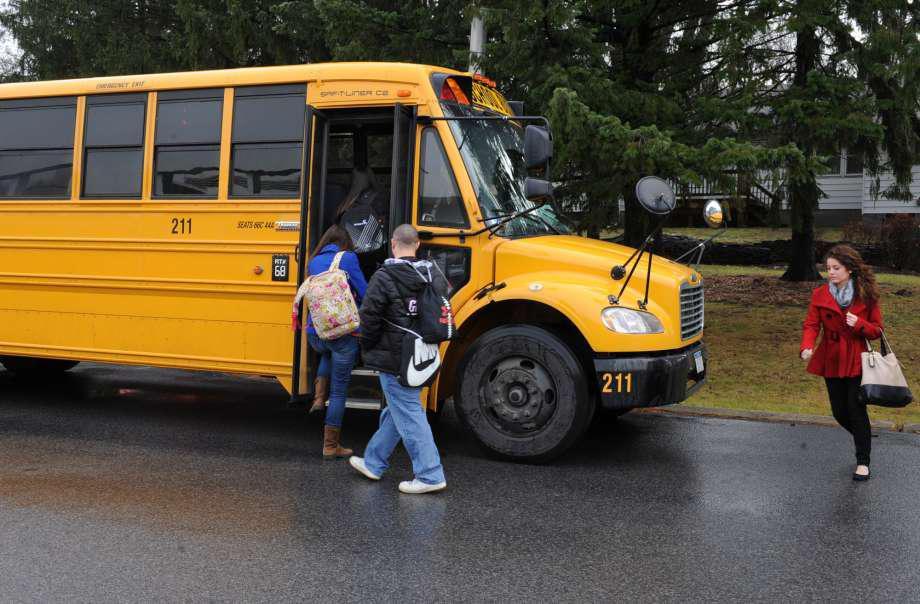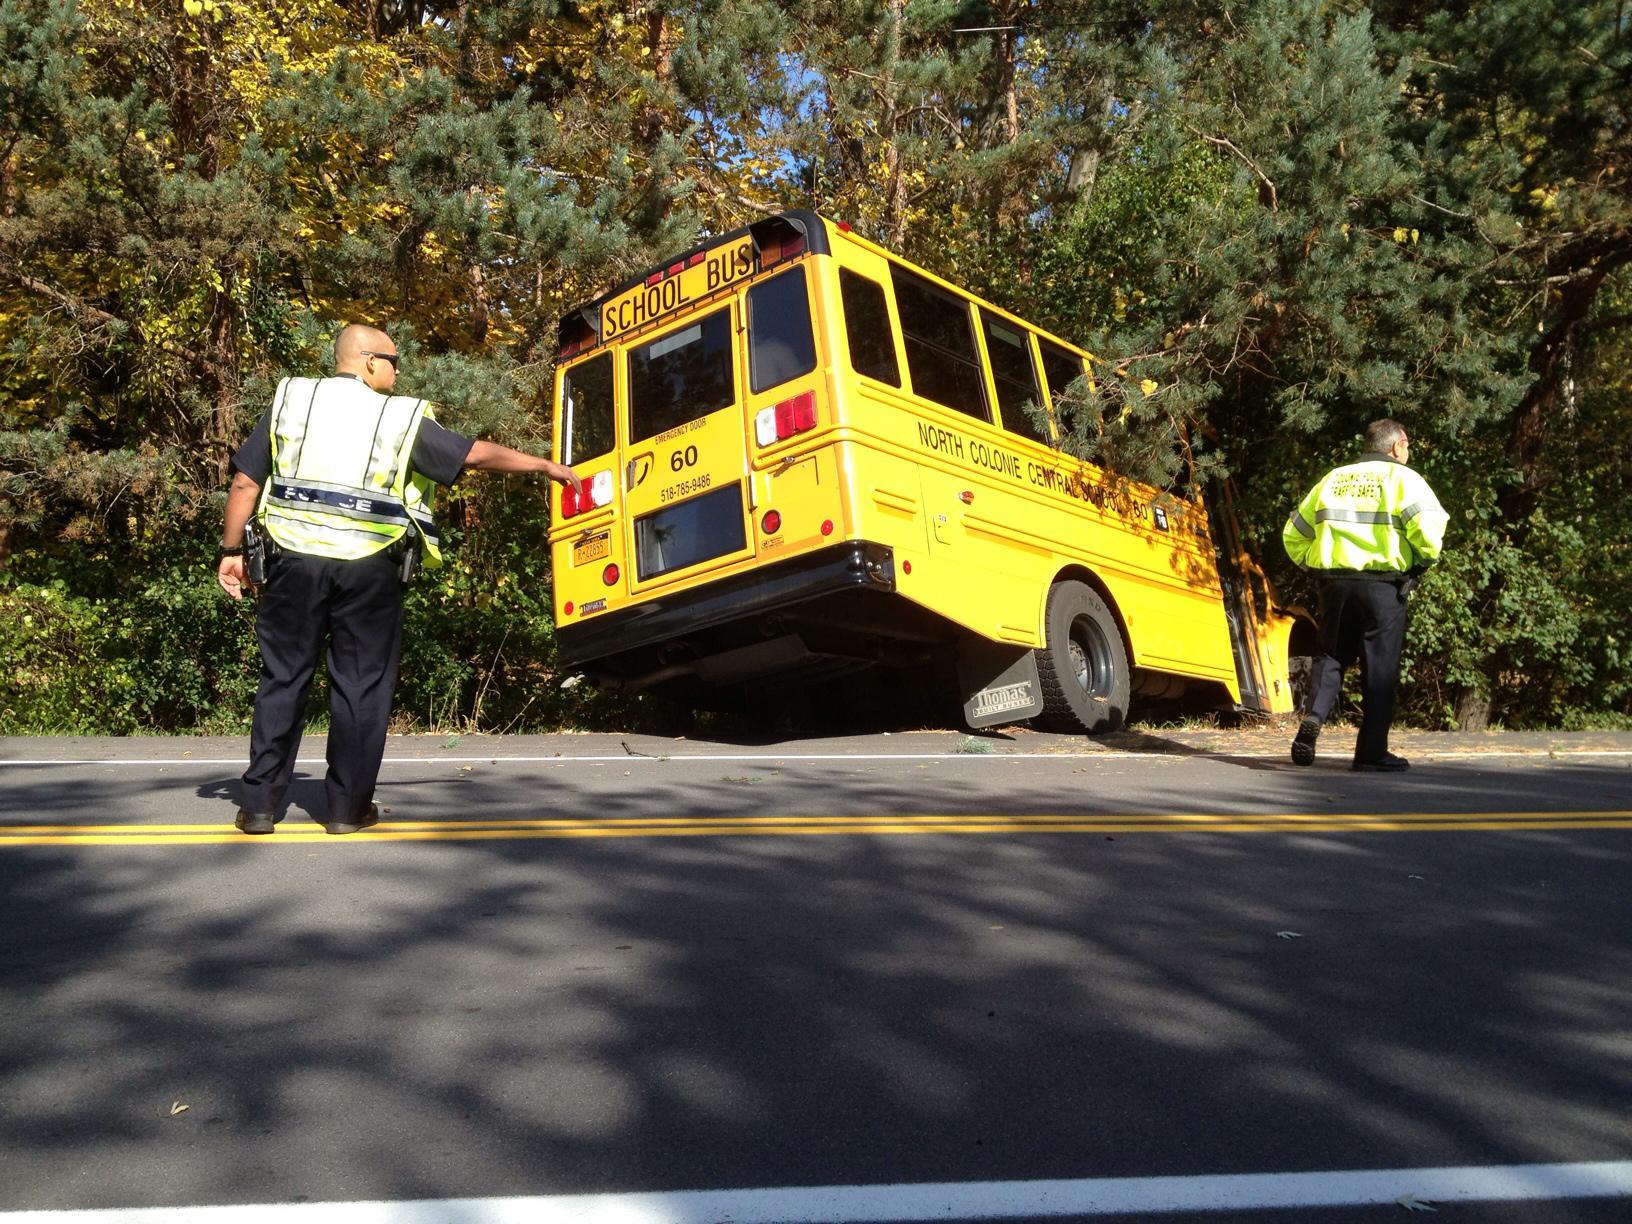The first image is the image on the left, the second image is the image on the right. Examine the images to the left and right. Is the description "All the buses are stopped or parked within close proximity to trees." accurate? Answer yes or no. Yes. The first image is the image on the left, the second image is the image on the right. Analyze the images presented: Is the assertion "There is a school bus that will need immediate repair." valid? Answer yes or no. Yes. 